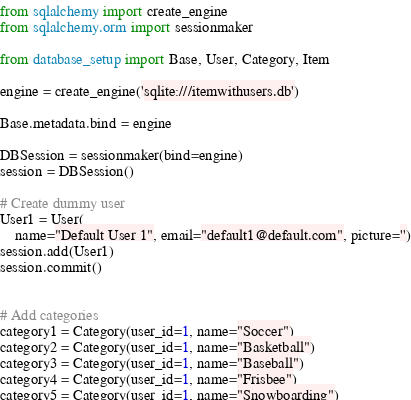Convert code to text. <code><loc_0><loc_0><loc_500><loc_500><_Python_>from sqlalchemy import create_engine
from sqlalchemy.orm import sessionmaker

from database_setup import Base, User, Category, Item

engine = create_engine('sqlite:///itemwithusers.db')

Base.metadata.bind = engine

DBSession = sessionmaker(bind=engine)
session = DBSession()

# Create dummy user
User1 = User(
    name="Default User 1", email="default1@default.com", picture='')
session.add(User1)
session.commit()


# Add categories
category1 = Category(user_id=1, name="Soccer")
category2 = Category(user_id=1, name="Basketball")
category3 = Category(user_id=1, name="Baseball")
category4 = Category(user_id=1, name="Frisbee")
category5 = Category(user_id=1, name="Snowboarding")</code> 